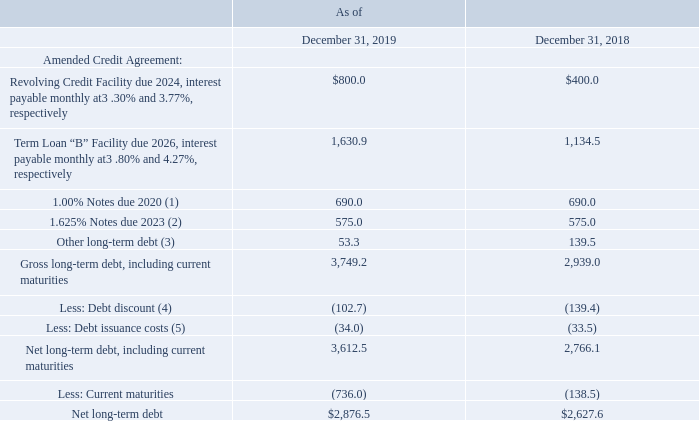Note 9: Long-Term Debt
The Company's long-term debt consists of the following (annualized interest rates, dollars in millions):
(1) Interest is payable on June 1 and December 1 of each year at 1.00% annually. (2) Interest is payable on April 15 and October 15 of each year at 1.625% annually. (3) Consists of U.S. real estate mortgages, term loans, revolving lines of credit, notes payable and other facilities at certain international locations where interest is payable weekly, monthly or quarterly, with interest rates between 1.00% and 4.00% and maturity dates between 2019 and 2022.
(4) Debt discount of $20.4 million and $41.6 million for the 1.00% Notes, $71.8 million and $88.5 million for the 1.625% Notes and $10.5 million and $9.3 million for the Term Loan "B" Facility, in each case as of December 31, 2019 and December 31, 2018, respectively. (5) Debt issuance costs of $2.8 million and $5.8 million for the 1.00% Notes, $6.9 million and $8.5 million for the 1.625% Notes and $24.3 million and $19.2 million for the Term Loan "B" Facility, in each case as of December 31, 2019 and December 31, 2018, respectively.
How much Interest is payable on June 1 and December 1 of each year? 1.00% annually. How much Interest is payable on April 15 and October 15 of each year? 1.625% annually. What is the net long-term debt for 2019?
Answer scale should be: million. $2,876.5. What is the change in Gross long-term debt, including current maturities from December 31, 2018 to 2019?
Answer scale should be: million. 3,749.2-2,939.0
Answer: 810.2. What is the change in Net long-term debt, including current maturities from year ended December 31, 2018 to 2019?
Answer scale should be: million. 3,612.5-2,766.1
Answer: 846.4. What is the average Gross long-term debt, including current maturities for December 31, 2018 to 2019?
Answer scale should be: million. (3,749.2+2,939.0) / 2
Answer: 3344.1. 